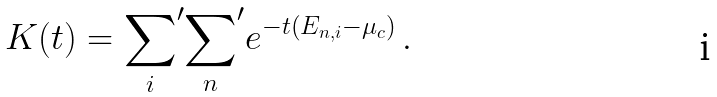<formula> <loc_0><loc_0><loc_500><loc_500>K ( t ) = { \sum _ { i } } ^ { \prime } { \sum _ { n } } ^ { \prime } e ^ { - t \left ( E _ { { n } , i } - \mu _ { c } \right ) } \, .</formula> 